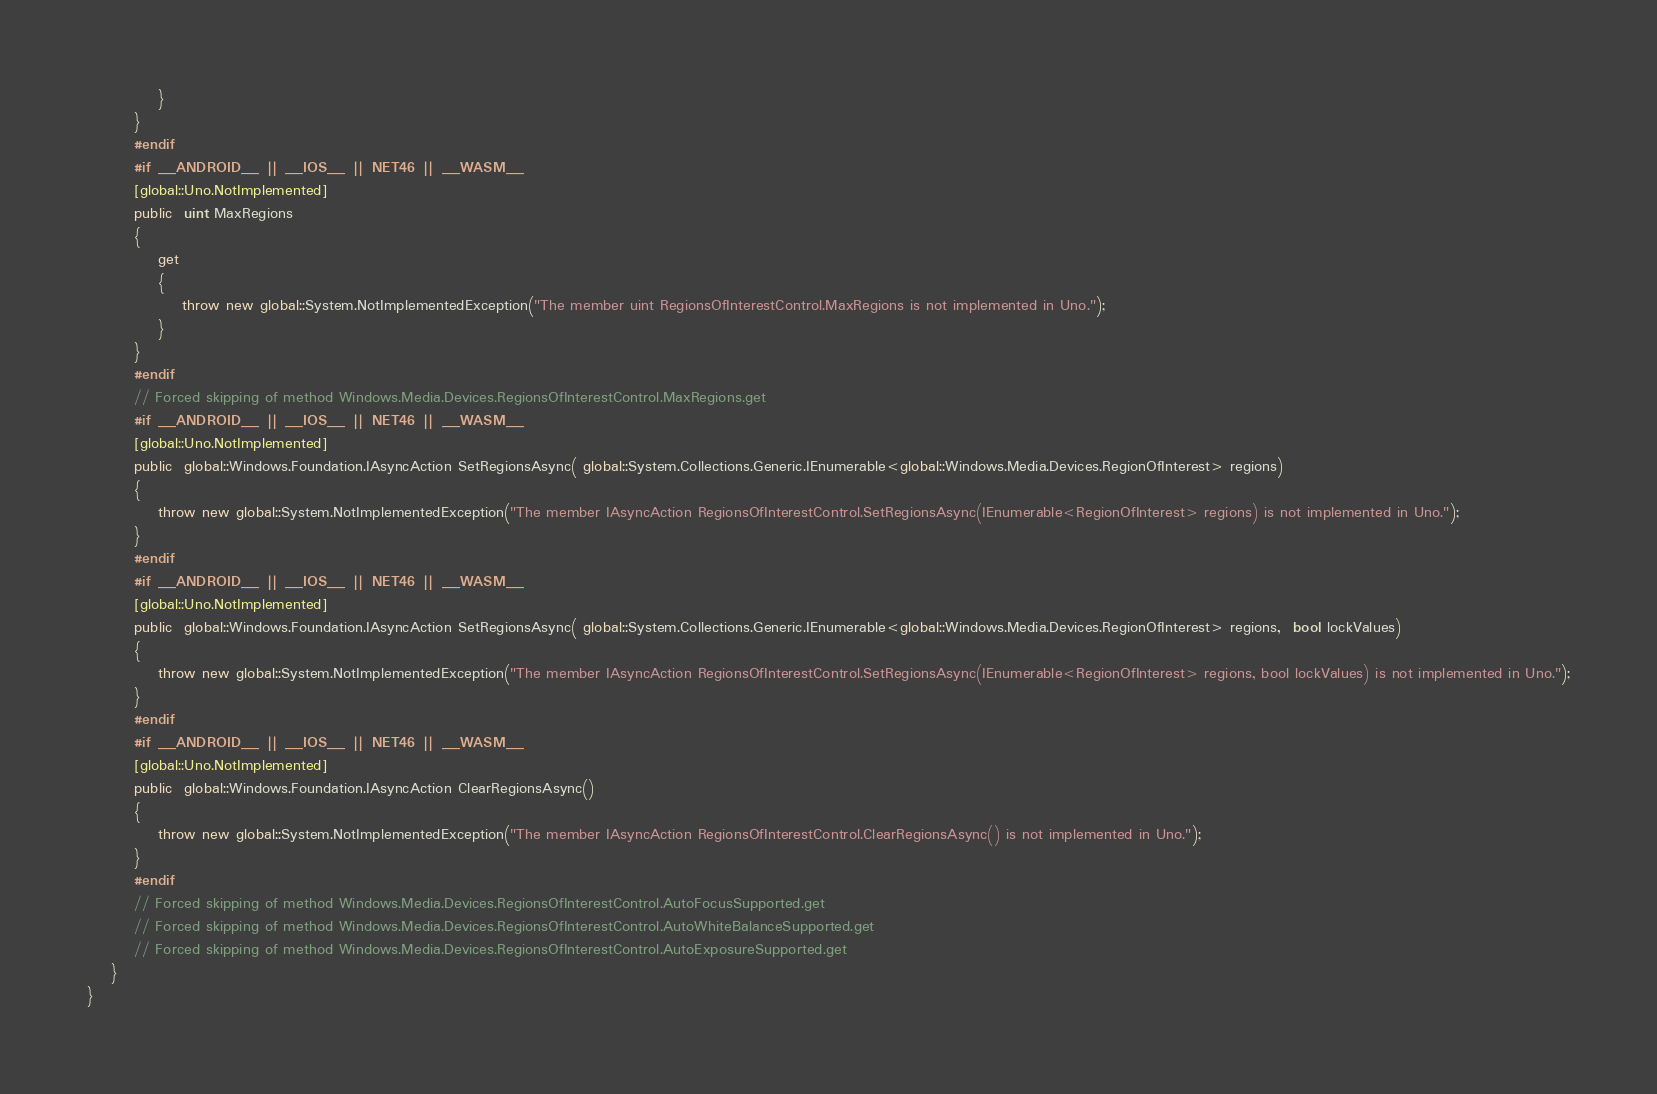<code> <loc_0><loc_0><loc_500><loc_500><_C#_>			}
		}
		#endif
		#if __ANDROID__ || __IOS__ || NET46 || __WASM__
		[global::Uno.NotImplemented]
		public  uint MaxRegions
		{
			get
			{
				throw new global::System.NotImplementedException("The member uint RegionsOfInterestControl.MaxRegions is not implemented in Uno.");
			}
		}
		#endif
		// Forced skipping of method Windows.Media.Devices.RegionsOfInterestControl.MaxRegions.get
		#if __ANDROID__ || __IOS__ || NET46 || __WASM__
		[global::Uno.NotImplemented]
		public  global::Windows.Foundation.IAsyncAction SetRegionsAsync( global::System.Collections.Generic.IEnumerable<global::Windows.Media.Devices.RegionOfInterest> regions)
		{
			throw new global::System.NotImplementedException("The member IAsyncAction RegionsOfInterestControl.SetRegionsAsync(IEnumerable<RegionOfInterest> regions) is not implemented in Uno.");
		}
		#endif
		#if __ANDROID__ || __IOS__ || NET46 || __WASM__
		[global::Uno.NotImplemented]
		public  global::Windows.Foundation.IAsyncAction SetRegionsAsync( global::System.Collections.Generic.IEnumerable<global::Windows.Media.Devices.RegionOfInterest> regions,  bool lockValues)
		{
			throw new global::System.NotImplementedException("The member IAsyncAction RegionsOfInterestControl.SetRegionsAsync(IEnumerable<RegionOfInterest> regions, bool lockValues) is not implemented in Uno.");
		}
		#endif
		#if __ANDROID__ || __IOS__ || NET46 || __WASM__
		[global::Uno.NotImplemented]
		public  global::Windows.Foundation.IAsyncAction ClearRegionsAsync()
		{
			throw new global::System.NotImplementedException("The member IAsyncAction RegionsOfInterestControl.ClearRegionsAsync() is not implemented in Uno.");
		}
		#endif
		// Forced skipping of method Windows.Media.Devices.RegionsOfInterestControl.AutoFocusSupported.get
		// Forced skipping of method Windows.Media.Devices.RegionsOfInterestControl.AutoWhiteBalanceSupported.get
		// Forced skipping of method Windows.Media.Devices.RegionsOfInterestControl.AutoExposureSupported.get
	}
}
</code> 